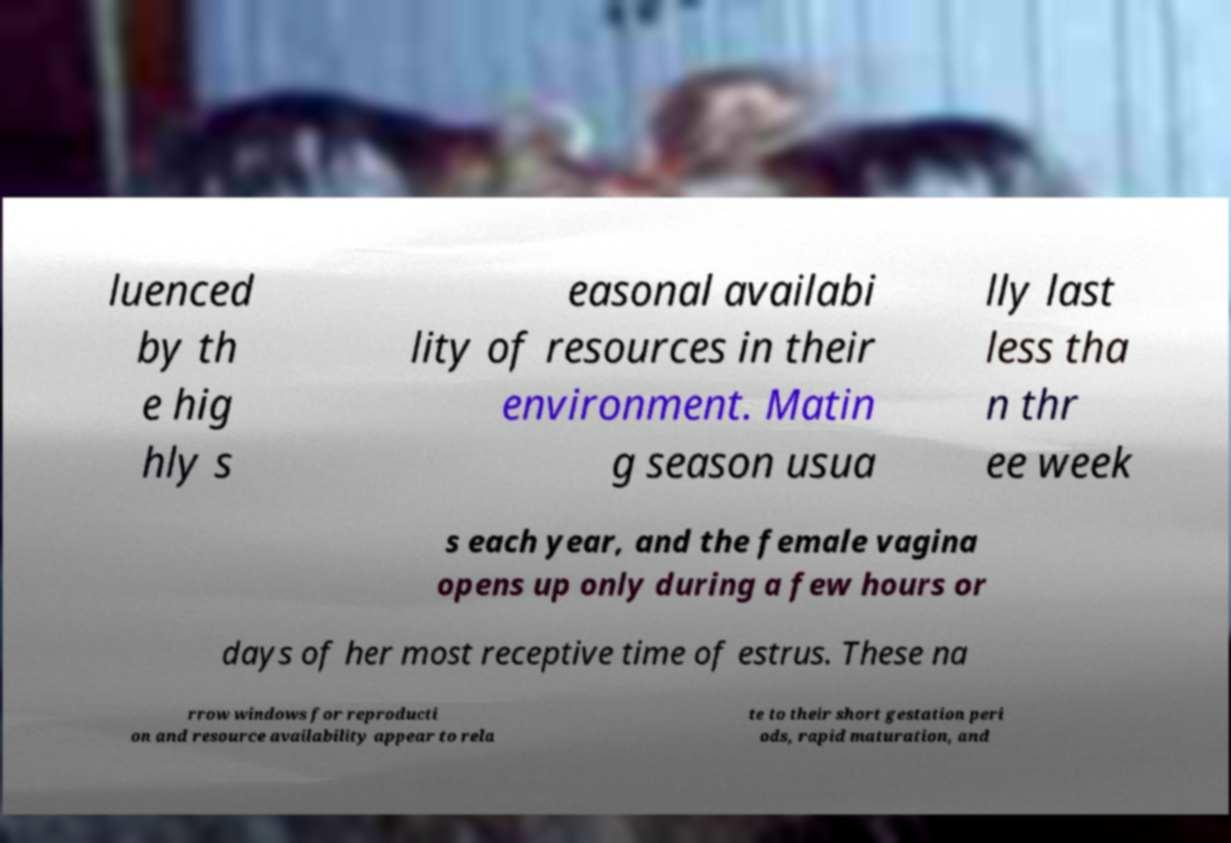Please identify and transcribe the text found in this image. luenced by th e hig hly s easonal availabi lity of resources in their environment. Matin g season usua lly last less tha n thr ee week s each year, and the female vagina opens up only during a few hours or days of her most receptive time of estrus. These na rrow windows for reproducti on and resource availability appear to rela te to their short gestation peri ods, rapid maturation, and 